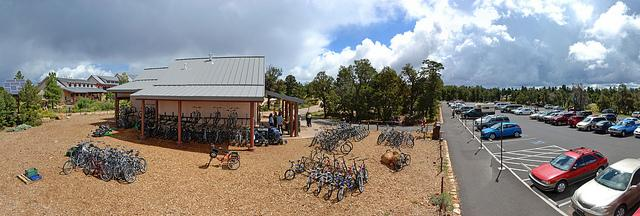What kind of facility can be found nearby? rest stop 